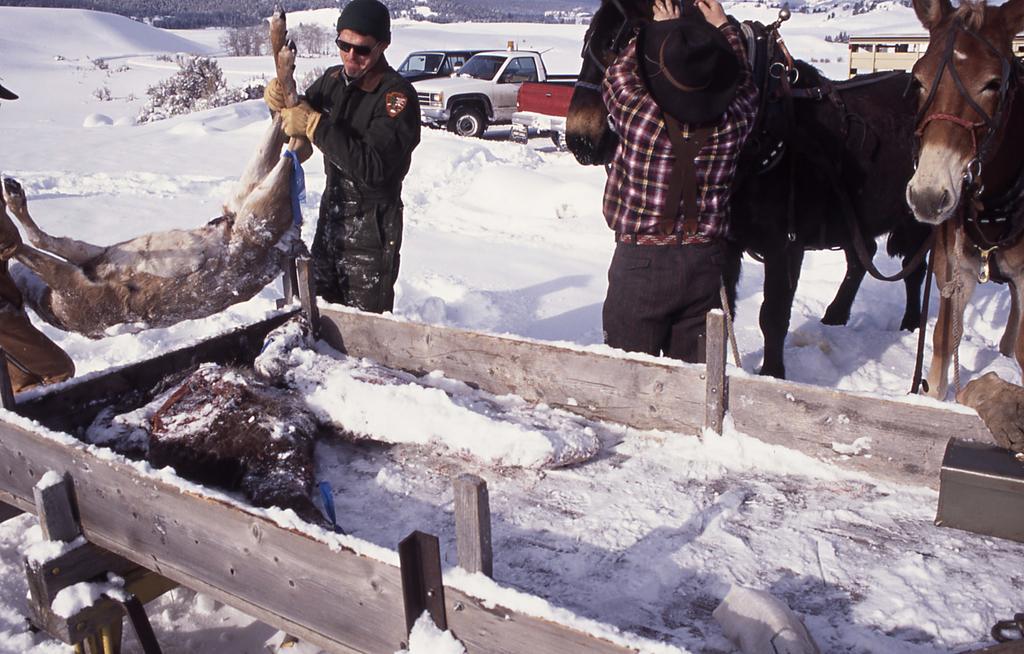Describe this image in one or two sentences. In this picture there is a person standing over here and holding the horse and as a person standing holding an animal in the backdrop there is snow and vehicles 